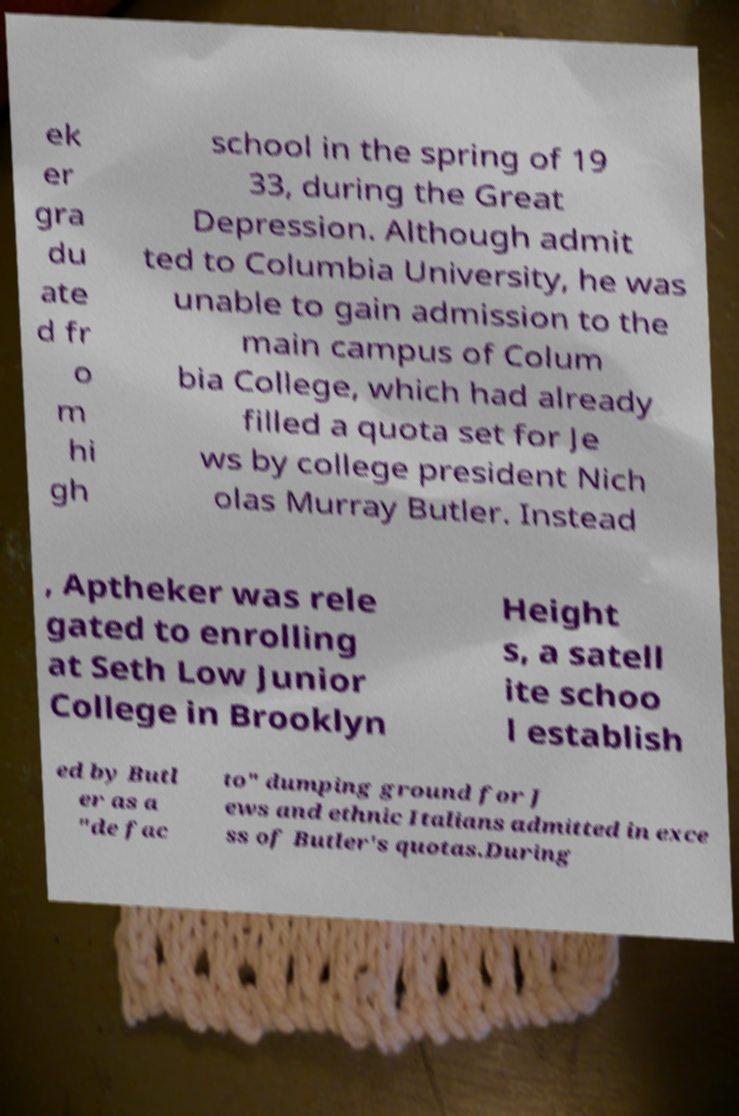What messages or text are displayed in this image? I need them in a readable, typed format. ek er gra du ate d fr o m hi gh school in the spring of 19 33, during the Great Depression. Although admit ted to Columbia University, he was unable to gain admission to the main campus of Colum bia College, which had already filled a quota set for Je ws by college president Nich olas Murray Butler. Instead , Aptheker was rele gated to enrolling at Seth Low Junior College in Brooklyn Height s, a satell ite schoo l establish ed by Butl er as a "de fac to" dumping ground for J ews and ethnic Italians admitted in exce ss of Butler's quotas.During 